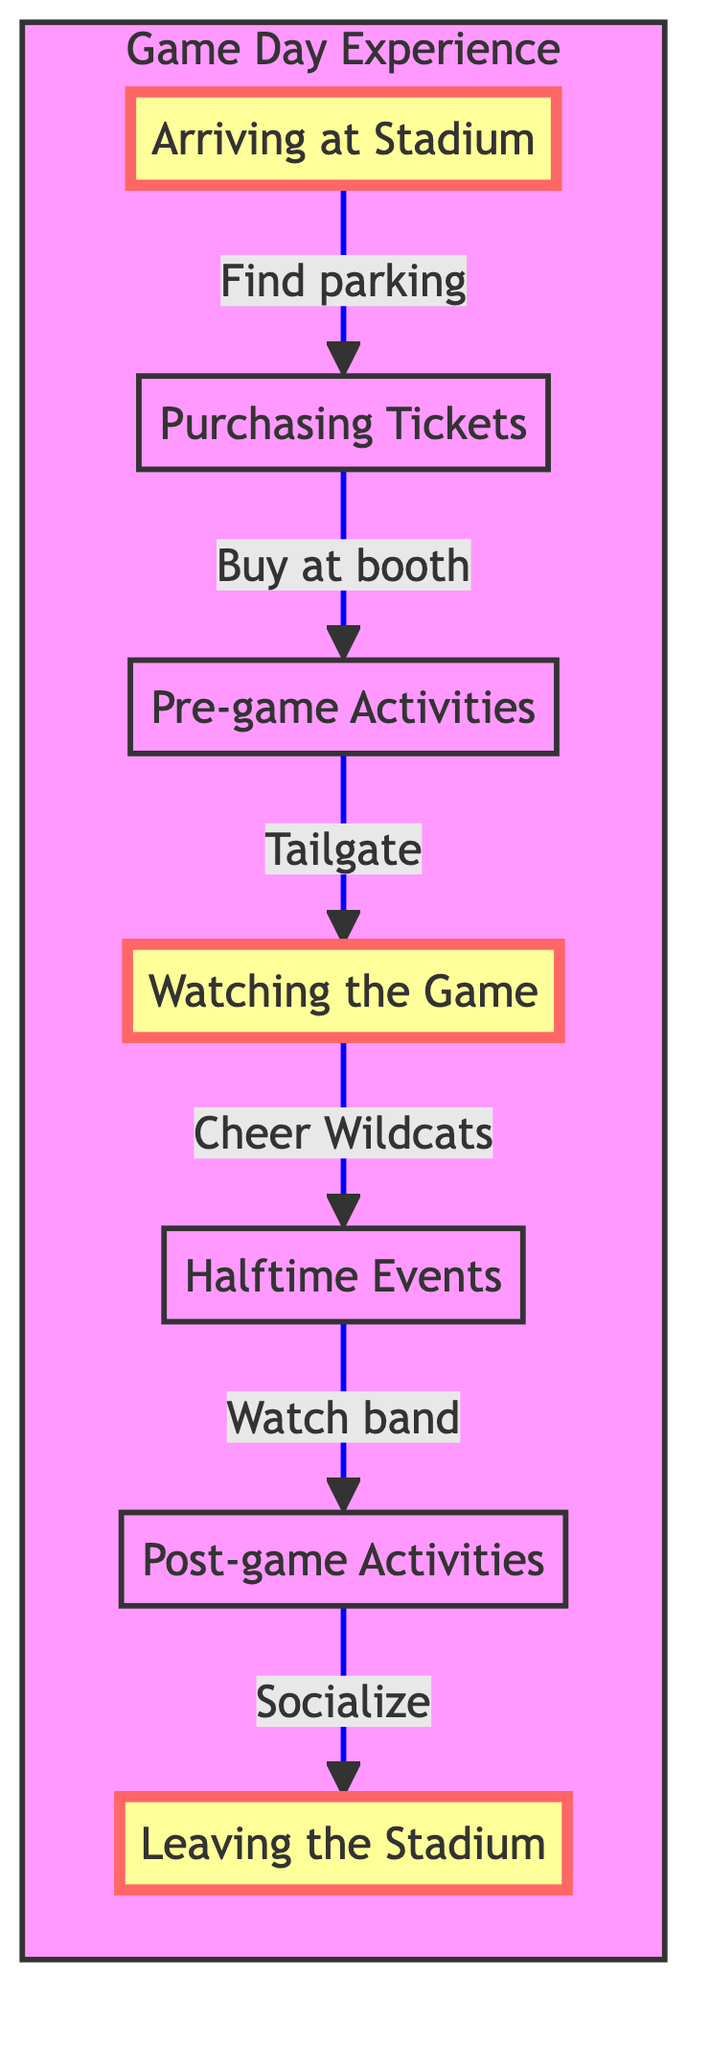What is the first step in the game day experience? The first step in the game day experience, as indicated in the diagram, is "Arriving at the Stadium." This is the starting point of the flowchart, showing the sequence of events.
Answer: Arriving at the Stadium How many total steps are there in the game day experience? By counting the nodes in the diagram, we can see there are seven steps: Arriving at the Stadium, Purchasing Tickets, Pre-game Activities, Watching the Game, Halftime Events, Post-game Activities, and Leaving the Stadium.
Answer: 7 What happens after purchasing tickets? The diagram shows that after the "Purchasing Tickets" step, the next step is "Pre-game Activities." This indicates the flow of activities to follow after buying the tickets.
Answer: Pre-game Activities What activity do fans participate in during halftime? According to the diagram, fans watch the "Davidson College marching band perform at halftime." This step specifically highlights the entertainment provided during the halftime period of the game.
Answer: Davidson College marching band What step comes before watching the game? The step that comes right before "Watching the Game" is "Pre-game Activities." The flow of the diagram illustrates that fans engage in pre-game activities prior to settling down to watch the game.
Answer: Pre-game Activities What is the last activity before leaving the stadium? The last activity indicated in the flowchart before "Leaving the Stadium" is "Post-game Activities." This shows that attending social activities occurs after the game before fans exit the area.
Answer: Post-game Activities Which step in the diagram highlights socializing? The "Post-game Activities" step emphasizes socializing as it mentions congratulating team players and participating in activities, which promote fan interaction and camaraderie.
Answer: Post-game Activities How do fans usually get to the stadium? Fans typically drive to the stadium, as the initial step "Arriving at the Stadium" refers to driving to the Richardson Stadium campus parking lot.
Answer: Driving 